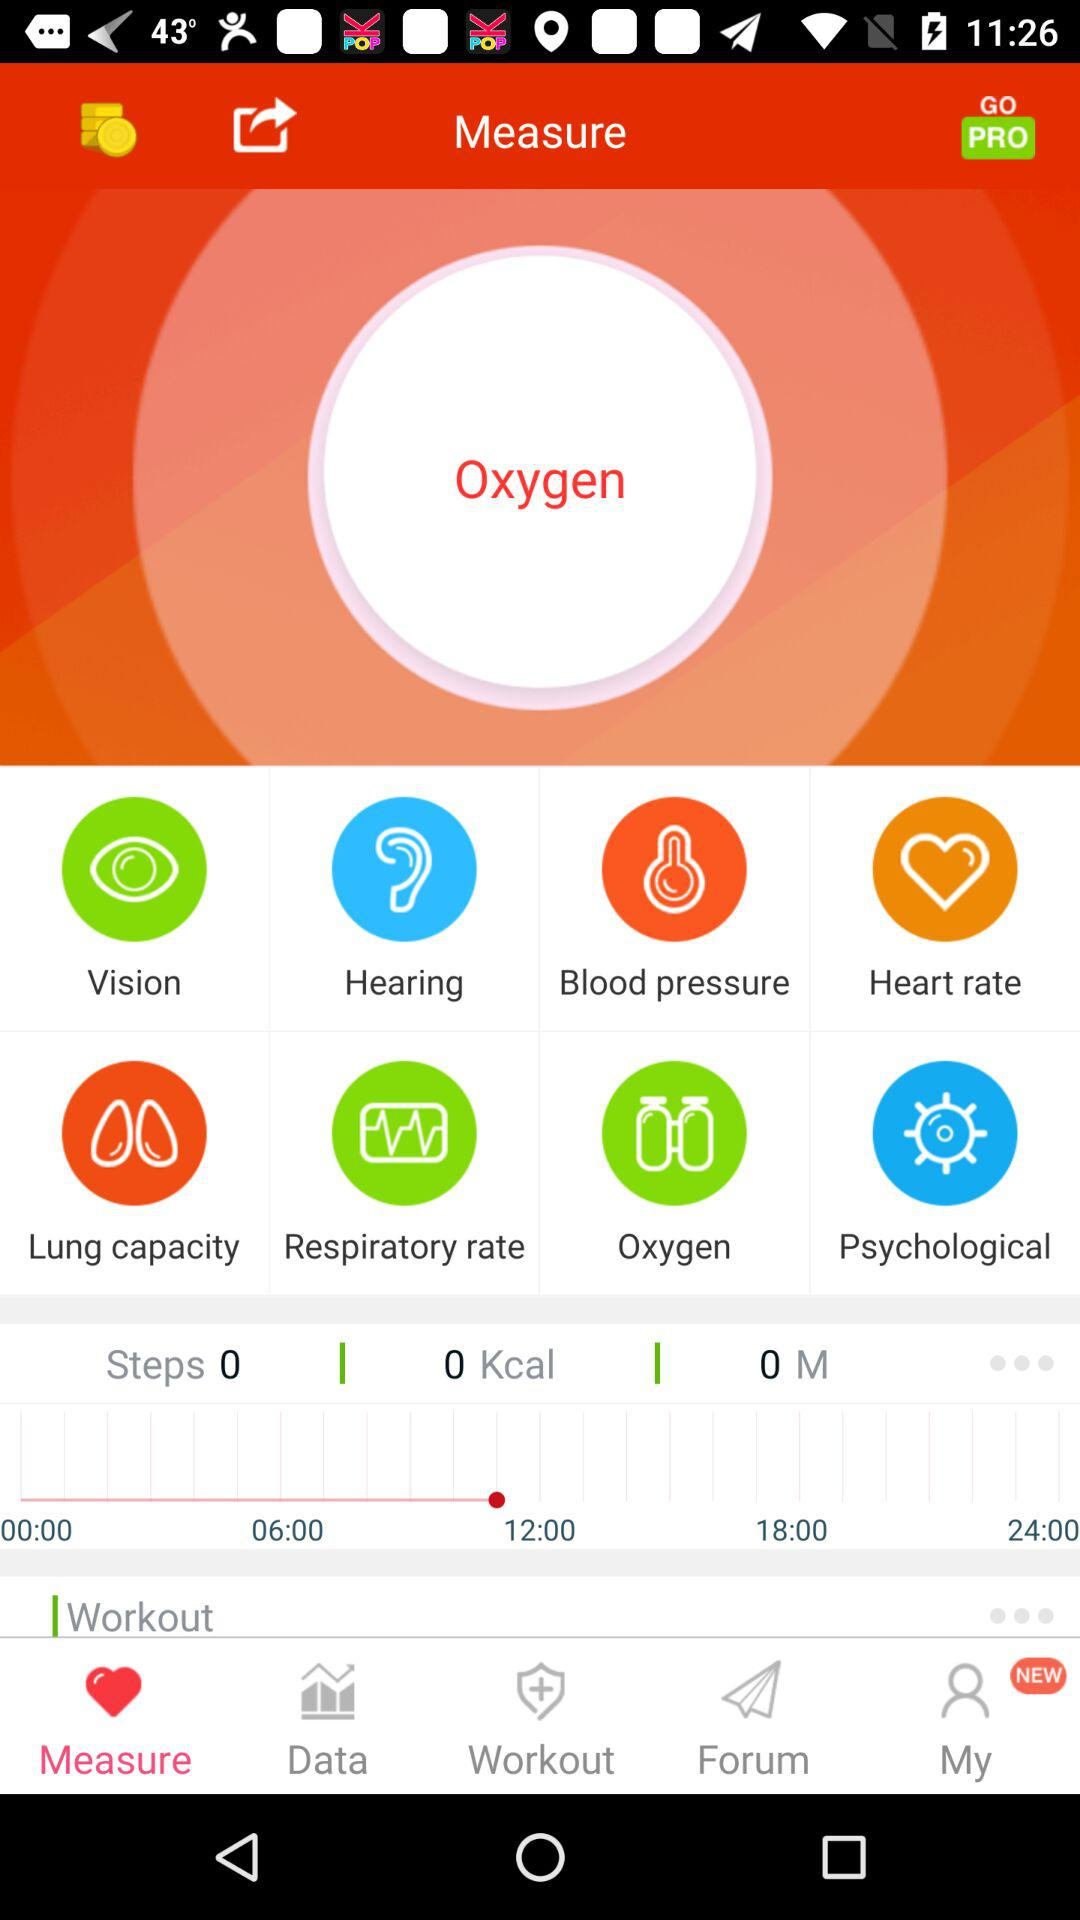What is the application name? The application name is "Measure". 